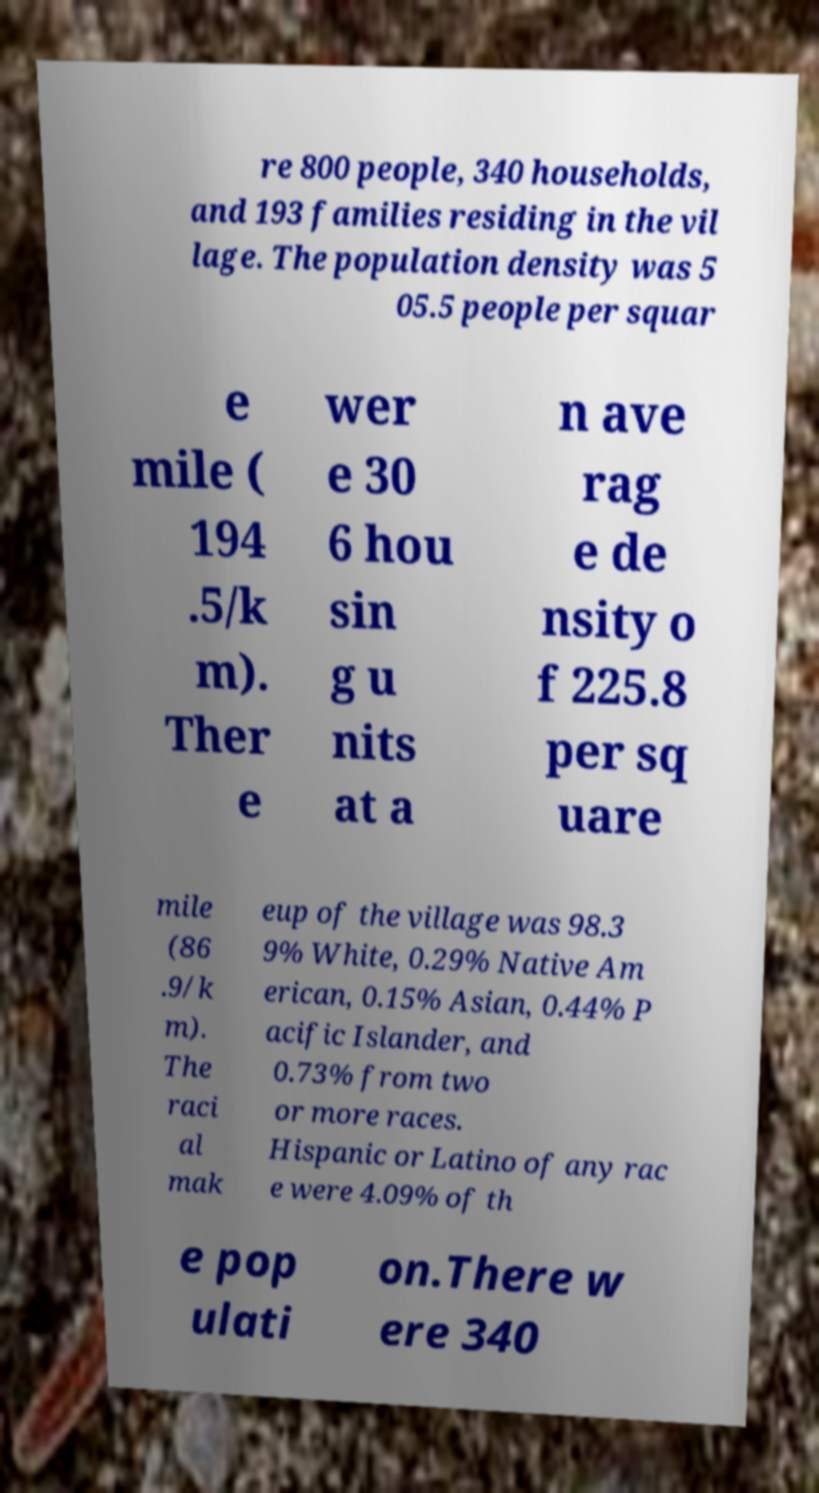What messages or text are displayed in this image? I need them in a readable, typed format. re 800 people, 340 households, and 193 families residing in the vil lage. The population density was 5 05.5 people per squar e mile ( 194 .5/k m). Ther e wer e 30 6 hou sin g u nits at a n ave rag e de nsity o f 225.8 per sq uare mile (86 .9/k m). The raci al mak eup of the village was 98.3 9% White, 0.29% Native Am erican, 0.15% Asian, 0.44% P acific Islander, and 0.73% from two or more races. Hispanic or Latino of any rac e were 4.09% of th e pop ulati on.There w ere 340 